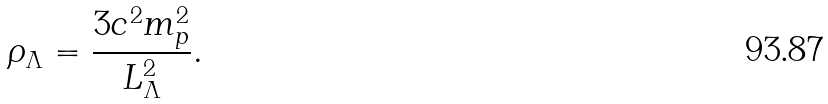<formula> <loc_0><loc_0><loc_500><loc_500>\rho _ { \Lambda } = \frac { 3 c ^ { 2 } m _ { p } ^ { 2 } } { L _ { \Lambda } ^ { 2 } } .</formula> 